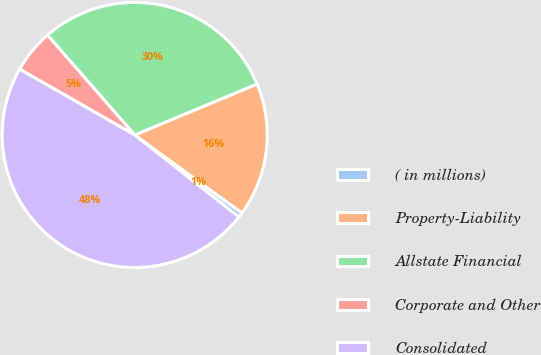Convert chart. <chart><loc_0><loc_0><loc_500><loc_500><pie_chart><fcel>( in millions)<fcel>Property-Liability<fcel>Allstate Financial<fcel>Corporate and Other<fcel>Consolidated<nl><fcel>0.61%<fcel>16.29%<fcel>30.14%<fcel>5.31%<fcel>47.65%<nl></chart> 